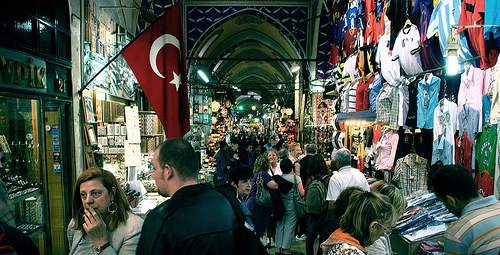<image>
Can you confirm if the shirt is on the man? No. The shirt is not positioned on the man. They may be near each other, but the shirt is not supported by or resting on top of the man. 